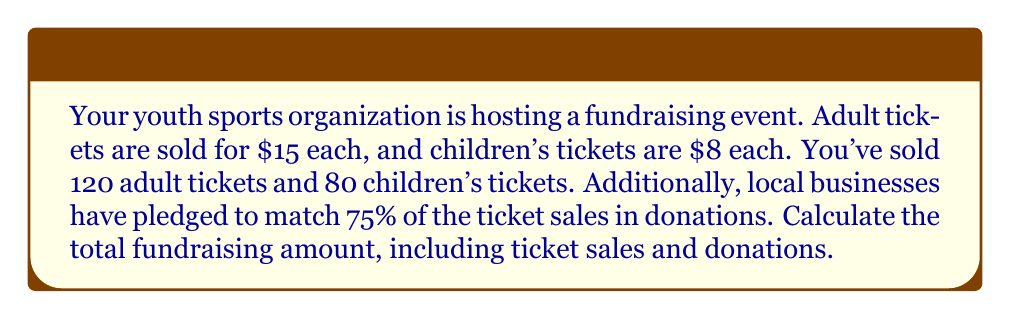Show me your answer to this math problem. Let's break this down step-by-step:

1. Calculate the revenue from adult tickets:
   $120 \times $15 = $1800$

2. Calculate the revenue from children's tickets:
   $80 \times $8 = $640$

3. Calculate the total ticket sales:
   $1800 + $640 = $2440$

4. Calculate the donation amount (75% of ticket sales):
   $2440 \times 0.75 = $1830$

5. Calculate the total fundraising amount:
   Total = Ticket sales + Donations
   $$ \text{Total} = 2440 + 1830 = $4270 $$

Therefore, the total fundraising amount is $4270.
Answer: $4270 